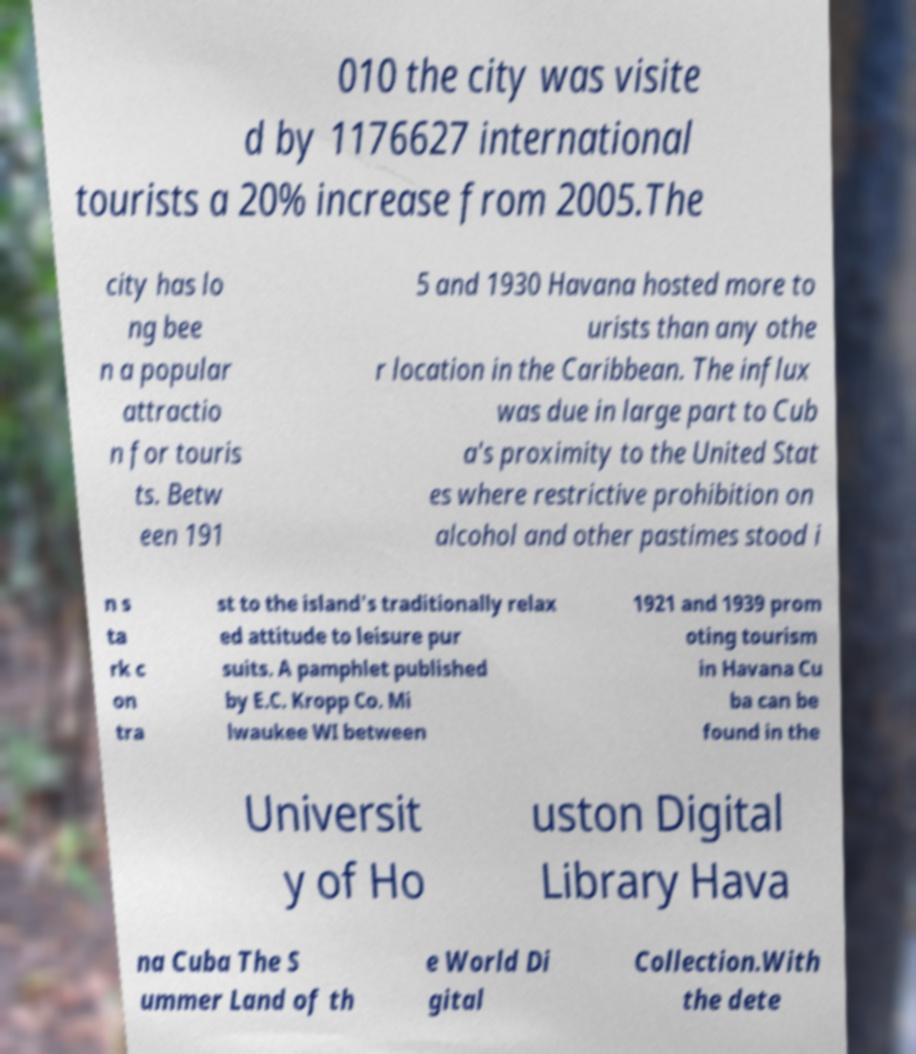Please identify and transcribe the text found in this image. 010 the city was visite d by 1176627 international tourists a 20% increase from 2005.The city has lo ng bee n a popular attractio n for touris ts. Betw een 191 5 and 1930 Havana hosted more to urists than any othe r location in the Caribbean. The influx was due in large part to Cub a's proximity to the United Stat es where restrictive prohibition on alcohol and other pastimes stood i n s ta rk c on tra st to the island's traditionally relax ed attitude to leisure pur suits. A pamphlet published by E.C. Kropp Co. Mi lwaukee WI between 1921 and 1939 prom oting tourism in Havana Cu ba can be found in the Universit y of Ho uston Digital Library Hava na Cuba The S ummer Land of th e World Di gital Collection.With the dete 